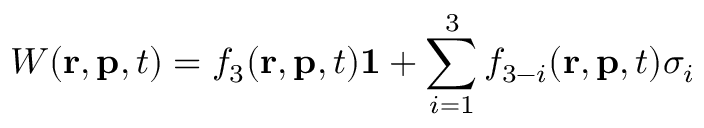Convert formula to latex. <formula><loc_0><loc_0><loc_500><loc_500>W ( r , p , t ) = f _ { 3 } ( r , p , t ) 1 + \sum _ { i = 1 } ^ { 3 } f _ { 3 - i } ( r , p , t ) \sigma _ { i }</formula> 